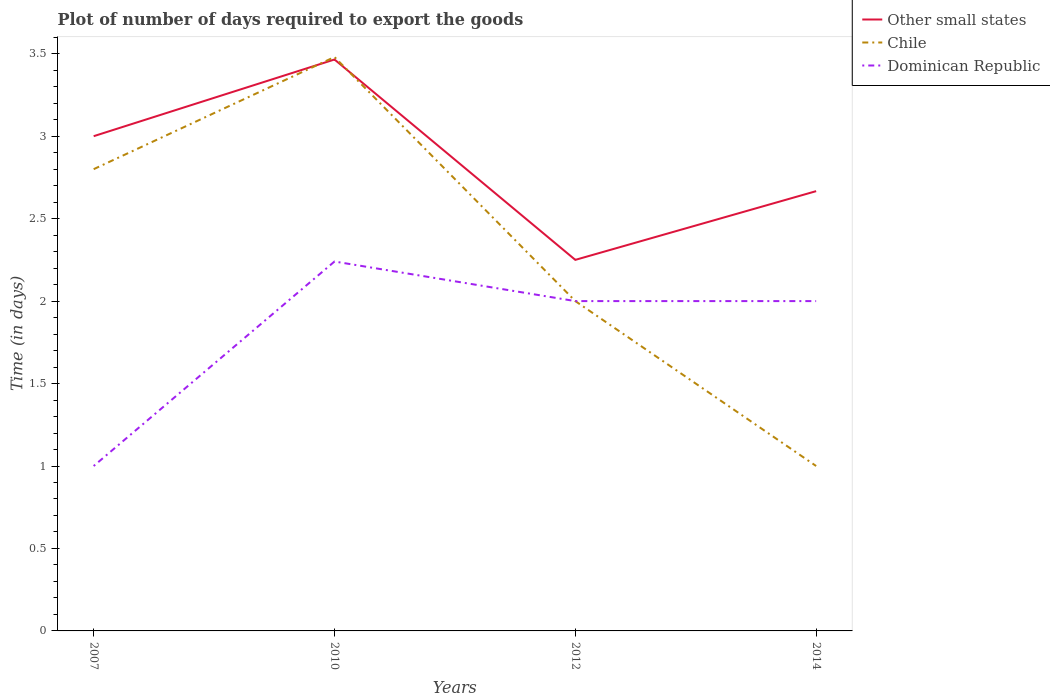How many different coloured lines are there?
Offer a terse response. 3. Across all years, what is the maximum time required to export goods in Chile?
Make the answer very short. 1. What is the total time required to export goods in Dominican Republic in the graph?
Your answer should be very brief. 0.24. What is the difference between the highest and the second highest time required to export goods in Chile?
Your answer should be compact. 2.48. What is the difference between the highest and the lowest time required to export goods in Dominican Republic?
Ensure brevity in your answer.  3. How many years are there in the graph?
Ensure brevity in your answer.  4. Are the values on the major ticks of Y-axis written in scientific E-notation?
Give a very brief answer. No. Does the graph contain any zero values?
Offer a terse response. No. Where does the legend appear in the graph?
Your response must be concise. Top right. How many legend labels are there?
Offer a terse response. 3. What is the title of the graph?
Your answer should be very brief. Plot of number of days required to export the goods. What is the label or title of the Y-axis?
Your answer should be compact. Time (in days). What is the Time (in days) of Other small states in 2010?
Your response must be concise. 3.46. What is the Time (in days) in Chile in 2010?
Offer a terse response. 3.48. What is the Time (in days) in Dominican Republic in 2010?
Provide a succinct answer. 2.24. What is the Time (in days) of Other small states in 2012?
Provide a short and direct response. 2.25. What is the Time (in days) of Dominican Republic in 2012?
Make the answer very short. 2. What is the Time (in days) in Other small states in 2014?
Ensure brevity in your answer.  2.67. Across all years, what is the maximum Time (in days) in Other small states?
Give a very brief answer. 3.46. Across all years, what is the maximum Time (in days) in Chile?
Provide a succinct answer. 3.48. Across all years, what is the maximum Time (in days) of Dominican Republic?
Make the answer very short. 2.24. Across all years, what is the minimum Time (in days) in Other small states?
Offer a very short reply. 2.25. Across all years, what is the minimum Time (in days) in Chile?
Your response must be concise. 1. What is the total Time (in days) of Other small states in the graph?
Keep it short and to the point. 11.38. What is the total Time (in days) in Chile in the graph?
Offer a terse response. 9.28. What is the total Time (in days) of Dominican Republic in the graph?
Offer a terse response. 7.24. What is the difference between the Time (in days) in Other small states in 2007 and that in 2010?
Make the answer very short. -0.47. What is the difference between the Time (in days) of Chile in 2007 and that in 2010?
Your response must be concise. -0.68. What is the difference between the Time (in days) in Dominican Republic in 2007 and that in 2010?
Keep it short and to the point. -1.24. What is the difference between the Time (in days) of Other small states in 2007 and that in 2012?
Offer a terse response. 0.75. What is the difference between the Time (in days) of Chile in 2007 and that in 2012?
Ensure brevity in your answer.  0.8. What is the difference between the Time (in days) of Dominican Republic in 2007 and that in 2012?
Provide a succinct answer. -1. What is the difference between the Time (in days) in Other small states in 2007 and that in 2014?
Your answer should be very brief. 0.33. What is the difference between the Time (in days) in Chile in 2007 and that in 2014?
Ensure brevity in your answer.  1.8. What is the difference between the Time (in days) of Dominican Republic in 2007 and that in 2014?
Offer a very short reply. -1. What is the difference between the Time (in days) in Other small states in 2010 and that in 2012?
Keep it short and to the point. 1.22. What is the difference between the Time (in days) in Chile in 2010 and that in 2012?
Ensure brevity in your answer.  1.48. What is the difference between the Time (in days) in Dominican Republic in 2010 and that in 2012?
Your response must be concise. 0.24. What is the difference between the Time (in days) in Other small states in 2010 and that in 2014?
Give a very brief answer. 0.8. What is the difference between the Time (in days) of Chile in 2010 and that in 2014?
Your answer should be very brief. 2.48. What is the difference between the Time (in days) of Dominican Republic in 2010 and that in 2014?
Provide a short and direct response. 0.24. What is the difference between the Time (in days) in Other small states in 2012 and that in 2014?
Give a very brief answer. -0.42. What is the difference between the Time (in days) in Chile in 2012 and that in 2014?
Give a very brief answer. 1. What is the difference between the Time (in days) of Dominican Republic in 2012 and that in 2014?
Keep it short and to the point. 0. What is the difference between the Time (in days) of Other small states in 2007 and the Time (in days) of Chile in 2010?
Offer a very short reply. -0.48. What is the difference between the Time (in days) of Other small states in 2007 and the Time (in days) of Dominican Republic in 2010?
Give a very brief answer. 0.76. What is the difference between the Time (in days) of Chile in 2007 and the Time (in days) of Dominican Republic in 2010?
Provide a succinct answer. 0.56. What is the difference between the Time (in days) of Other small states in 2007 and the Time (in days) of Dominican Republic in 2012?
Provide a succinct answer. 1. What is the difference between the Time (in days) of Chile in 2007 and the Time (in days) of Dominican Republic in 2012?
Your answer should be compact. 0.8. What is the difference between the Time (in days) of Other small states in 2007 and the Time (in days) of Dominican Republic in 2014?
Provide a short and direct response. 1. What is the difference between the Time (in days) in Other small states in 2010 and the Time (in days) in Chile in 2012?
Provide a short and direct response. 1.47. What is the difference between the Time (in days) of Other small states in 2010 and the Time (in days) of Dominican Republic in 2012?
Give a very brief answer. 1.47. What is the difference between the Time (in days) of Chile in 2010 and the Time (in days) of Dominican Republic in 2012?
Offer a very short reply. 1.48. What is the difference between the Time (in days) of Other small states in 2010 and the Time (in days) of Chile in 2014?
Your answer should be compact. 2.46. What is the difference between the Time (in days) in Other small states in 2010 and the Time (in days) in Dominican Republic in 2014?
Offer a terse response. 1.47. What is the difference between the Time (in days) of Chile in 2010 and the Time (in days) of Dominican Republic in 2014?
Your answer should be very brief. 1.48. What is the difference between the Time (in days) in Other small states in 2012 and the Time (in days) in Chile in 2014?
Offer a terse response. 1.25. What is the difference between the Time (in days) of Other small states in 2012 and the Time (in days) of Dominican Republic in 2014?
Your response must be concise. 0.25. What is the average Time (in days) of Other small states per year?
Your response must be concise. 2.85. What is the average Time (in days) in Chile per year?
Your response must be concise. 2.32. What is the average Time (in days) of Dominican Republic per year?
Give a very brief answer. 1.81. In the year 2007, what is the difference between the Time (in days) in Other small states and Time (in days) in Chile?
Offer a very short reply. 0.2. In the year 2010, what is the difference between the Time (in days) in Other small states and Time (in days) in Chile?
Offer a very short reply. -0.01. In the year 2010, what is the difference between the Time (in days) in Other small states and Time (in days) in Dominican Republic?
Your response must be concise. 1.23. In the year 2010, what is the difference between the Time (in days) of Chile and Time (in days) of Dominican Republic?
Offer a terse response. 1.24. In the year 2012, what is the difference between the Time (in days) in Other small states and Time (in days) in Chile?
Provide a short and direct response. 0.25. In the year 2012, what is the difference between the Time (in days) of Other small states and Time (in days) of Dominican Republic?
Provide a short and direct response. 0.25. In the year 2014, what is the difference between the Time (in days) of Chile and Time (in days) of Dominican Republic?
Keep it short and to the point. -1. What is the ratio of the Time (in days) of Other small states in 2007 to that in 2010?
Ensure brevity in your answer.  0.87. What is the ratio of the Time (in days) of Chile in 2007 to that in 2010?
Offer a very short reply. 0.8. What is the ratio of the Time (in days) of Dominican Republic in 2007 to that in 2010?
Your response must be concise. 0.45. What is the ratio of the Time (in days) in Other small states in 2007 to that in 2012?
Keep it short and to the point. 1.33. What is the ratio of the Time (in days) in Chile in 2007 to that in 2014?
Give a very brief answer. 2.8. What is the ratio of the Time (in days) in Other small states in 2010 to that in 2012?
Keep it short and to the point. 1.54. What is the ratio of the Time (in days) of Chile in 2010 to that in 2012?
Give a very brief answer. 1.74. What is the ratio of the Time (in days) in Dominican Republic in 2010 to that in 2012?
Provide a short and direct response. 1.12. What is the ratio of the Time (in days) in Other small states in 2010 to that in 2014?
Give a very brief answer. 1.3. What is the ratio of the Time (in days) in Chile in 2010 to that in 2014?
Give a very brief answer. 3.48. What is the ratio of the Time (in days) of Dominican Republic in 2010 to that in 2014?
Give a very brief answer. 1.12. What is the ratio of the Time (in days) of Other small states in 2012 to that in 2014?
Give a very brief answer. 0.84. What is the ratio of the Time (in days) of Chile in 2012 to that in 2014?
Make the answer very short. 2. What is the ratio of the Time (in days) in Dominican Republic in 2012 to that in 2014?
Your answer should be compact. 1. What is the difference between the highest and the second highest Time (in days) of Other small states?
Your answer should be compact. 0.47. What is the difference between the highest and the second highest Time (in days) in Chile?
Offer a very short reply. 0.68. What is the difference between the highest and the second highest Time (in days) of Dominican Republic?
Give a very brief answer. 0.24. What is the difference between the highest and the lowest Time (in days) in Other small states?
Provide a short and direct response. 1.22. What is the difference between the highest and the lowest Time (in days) of Chile?
Give a very brief answer. 2.48. What is the difference between the highest and the lowest Time (in days) of Dominican Republic?
Offer a very short reply. 1.24. 